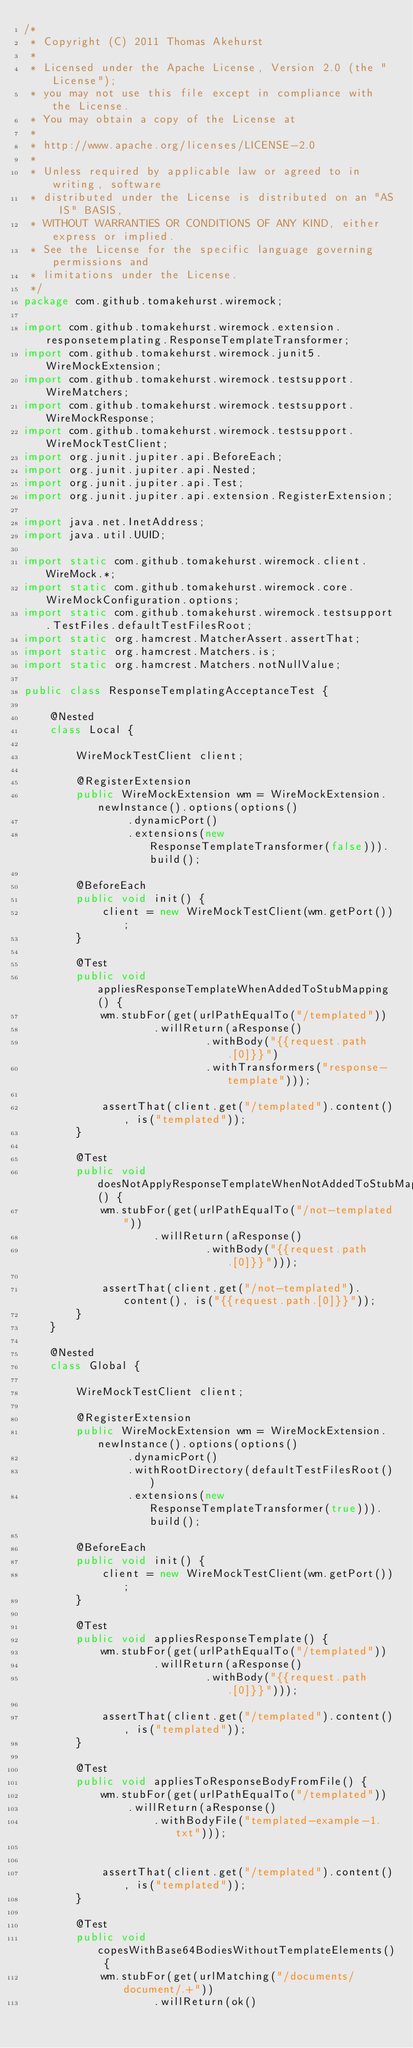Convert code to text. <code><loc_0><loc_0><loc_500><loc_500><_Java_>/*
 * Copyright (C) 2011 Thomas Akehurst
 *
 * Licensed under the Apache License, Version 2.0 (the "License");
 * you may not use this file except in compliance with the License.
 * You may obtain a copy of the License at
 *
 * http://www.apache.org/licenses/LICENSE-2.0
 *
 * Unless required by applicable law or agreed to in writing, software
 * distributed under the License is distributed on an "AS IS" BASIS,
 * WITHOUT WARRANTIES OR CONDITIONS OF ANY KIND, either express or implied.
 * See the License for the specific language governing permissions and
 * limitations under the License.
 */
package com.github.tomakehurst.wiremock;

import com.github.tomakehurst.wiremock.extension.responsetemplating.ResponseTemplateTransformer;
import com.github.tomakehurst.wiremock.junit5.WireMockExtension;
import com.github.tomakehurst.wiremock.testsupport.WireMatchers;
import com.github.tomakehurst.wiremock.testsupport.WireMockResponse;
import com.github.tomakehurst.wiremock.testsupport.WireMockTestClient;
import org.junit.jupiter.api.BeforeEach;
import org.junit.jupiter.api.Nested;
import org.junit.jupiter.api.Test;
import org.junit.jupiter.api.extension.RegisterExtension;

import java.net.InetAddress;
import java.util.UUID;

import static com.github.tomakehurst.wiremock.client.WireMock.*;
import static com.github.tomakehurst.wiremock.core.WireMockConfiguration.options;
import static com.github.tomakehurst.wiremock.testsupport.TestFiles.defaultTestFilesRoot;
import static org.hamcrest.MatcherAssert.assertThat;
import static org.hamcrest.Matchers.is;
import static org.hamcrest.Matchers.notNullValue;

public class ResponseTemplatingAcceptanceTest {

    @Nested
    class Local {

        WireMockTestClient client;

        @RegisterExtension
        public WireMockExtension wm = WireMockExtension.newInstance().options(options()
                .dynamicPort()
                .extensions(new ResponseTemplateTransformer(false))).build();

        @BeforeEach
        public void init() {
            client = new WireMockTestClient(wm.getPort());
        }

        @Test
        public void appliesResponseTemplateWhenAddedToStubMapping() {
            wm.stubFor(get(urlPathEqualTo("/templated"))
                    .willReturn(aResponse()
                            .withBody("{{request.path.[0]}}")
                            .withTransformers("response-template")));

            assertThat(client.get("/templated").content(), is("templated"));
        }

        @Test
        public void doesNotApplyResponseTemplateWhenNotAddedToStubMapping() {
            wm.stubFor(get(urlPathEqualTo("/not-templated"))
                    .willReturn(aResponse()
                            .withBody("{{request.path.[0]}}")));

            assertThat(client.get("/not-templated").content(), is("{{request.path.[0]}}"));
        }
    }

    @Nested
    class Global {

        WireMockTestClient client;

        @RegisterExtension
        public WireMockExtension wm = WireMockExtension.newInstance().options(options()
                .dynamicPort()
                .withRootDirectory(defaultTestFilesRoot())
                .extensions(new ResponseTemplateTransformer(true))).build();

        @BeforeEach
        public void init() {
            client = new WireMockTestClient(wm.getPort());
        }

        @Test
        public void appliesResponseTemplate() {
            wm.stubFor(get(urlPathEqualTo("/templated"))
                    .willReturn(aResponse()
                            .withBody("{{request.path.[0]}}")));

            assertThat(client.get("/templated").content(), is("templated"));
        }

        @Test
        public void appliesToResponseBodyFromFile() {
            wm.stubFor(get(urlPathEqualTo("/templated"))
                .willReturn(aResponse()
                    .withBodyFile("templated-example-1.txt")));


            assertThat(client.get("/templated").content(), is("templated"));
        }

        @Test
        public void copesWithBase64BodiesWithoutTemplateElements() {
            wm.stubFor(get(urlMatching("/documents/document/.+"))
                    .willReturn(ok()</code> 